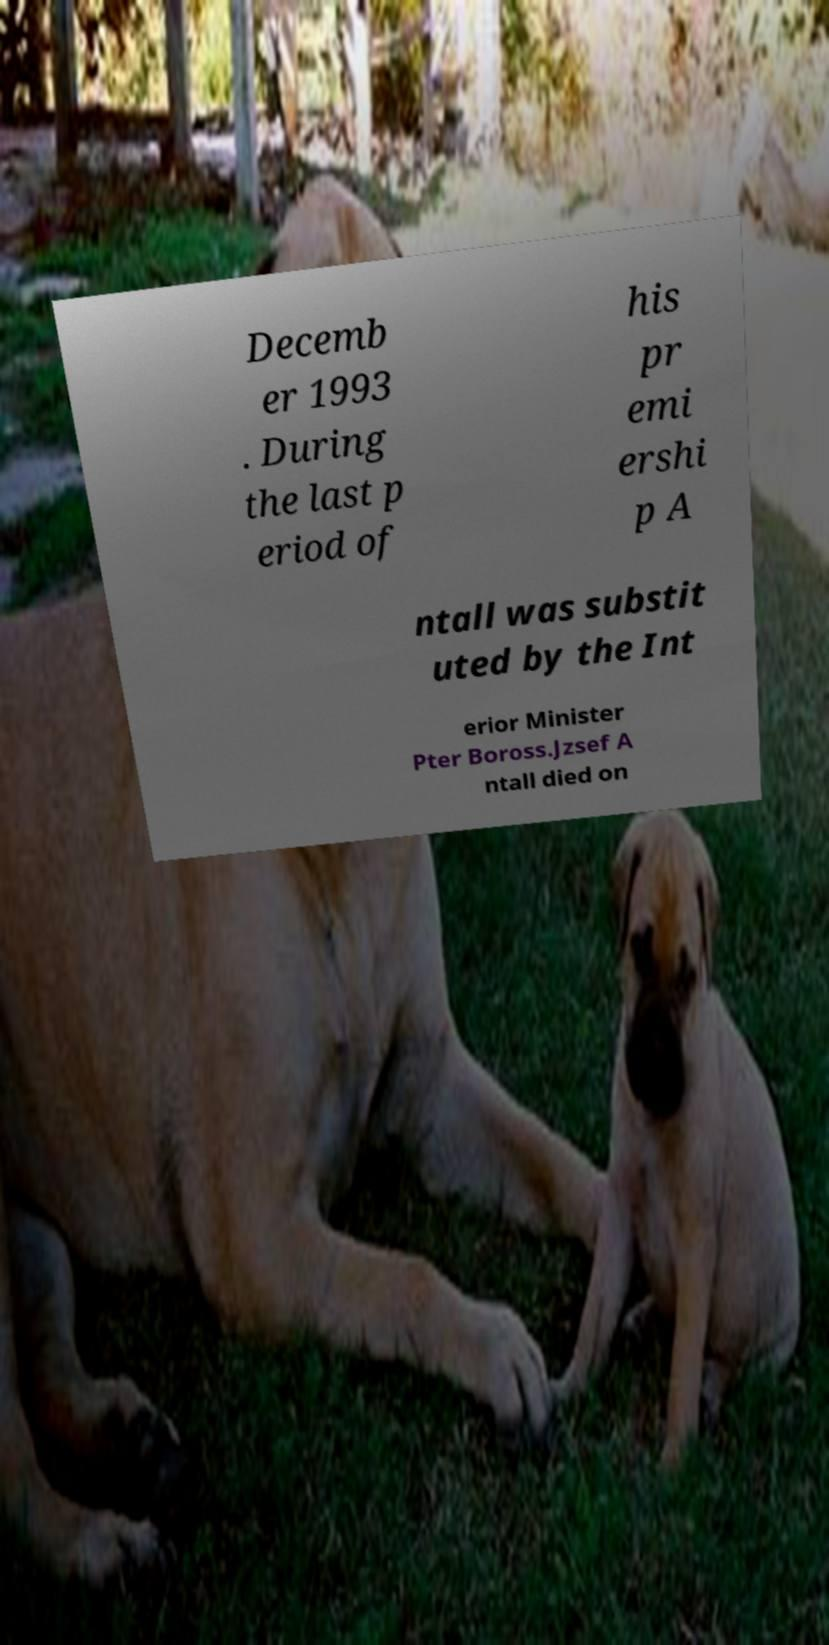I need the written content from this picture converted into text. Can you do that? Decemb er 1993 . During the last p eriod of his pr emi ershi p A ntall was substit uted by the Int erior Minister Pter Boross.Jzsef A ntall died on 